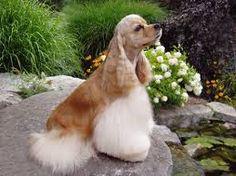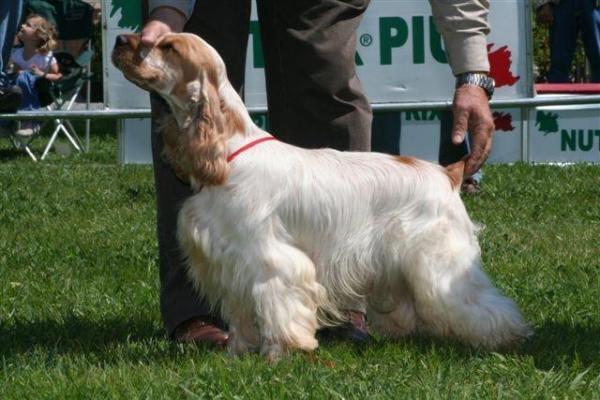The first image is the image on the left, the second image is the image on the right. For the images shown, is this caption "A person is tending to the dog in one of the images." true? Answer yes or no. Yes. 